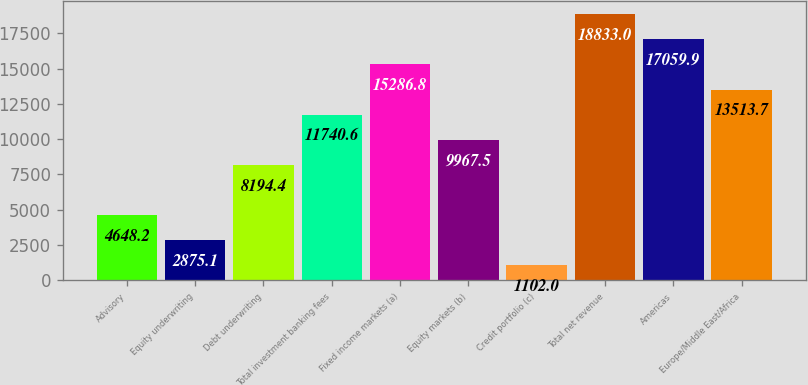Convert chart to OTSL. <chart><loc_0><loc_0><loc_500><loc_500><bar_chart><fcel>Advisory<fcel>Equity underwriting<fcel>Debt underwriting<fcel>Total investment banking fees<fcel>Fixed income markets (a)<fcel>Equity markets (b)<fcel>Credit portfolio (c)<fcel>Total net revenue<fcel>Americas<fcel>Europe/Middle East/Africa<nl><fcel>4648.2<fcel>2875.1<fcel>8194.4<fcel>11740.6<fcel>15286.8<fcel>9967.5<fcel>1102<fcel>18833<fcel>17059.9<fcel>13513.7<nl></chart> 